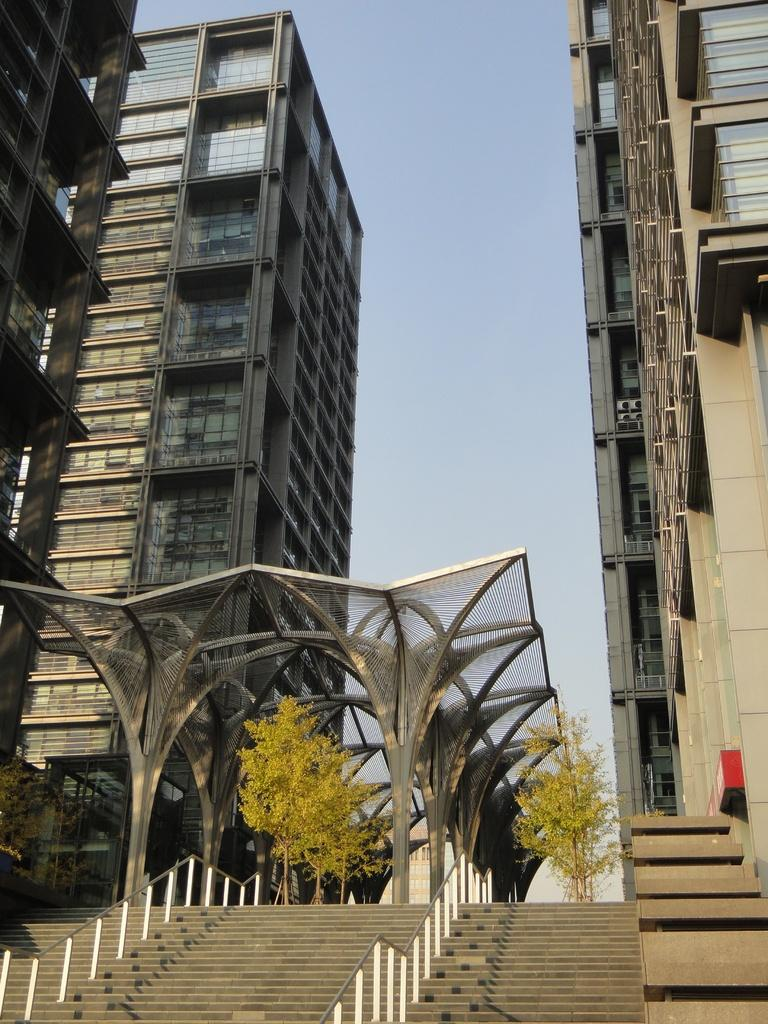What type of architectural feature is present in the image? There are steps in the image. What type of natural elements can be seen in the image? There are trees in the image. What type of man-made structures are visible in the image? There are buildings in the image. What can be seen in the background of the image? The sky is visible in the background of the image. Can you see a zebra wearing a scarf in the image? No, there is no zebra or scarf present in the image. Are there any rats visible in the image? No, there are no rats present in the image. 